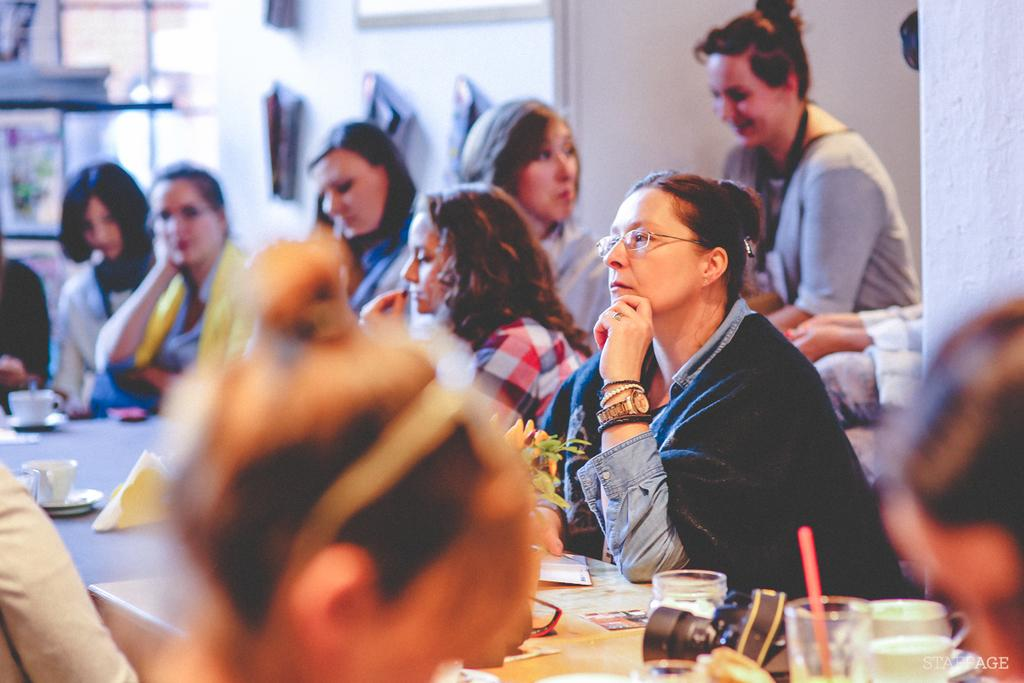What is the main subject of the image? The main subject of the image is a group of women. What are the women doing in the image? The women are sitting at a table. What type of railway is visible in the image? There is no railway present in the image; it features a group of women sitting at a table. What song are the women singing in the image? There is no indication in the image that the women are singing, so it cannot be determined from the picture. 